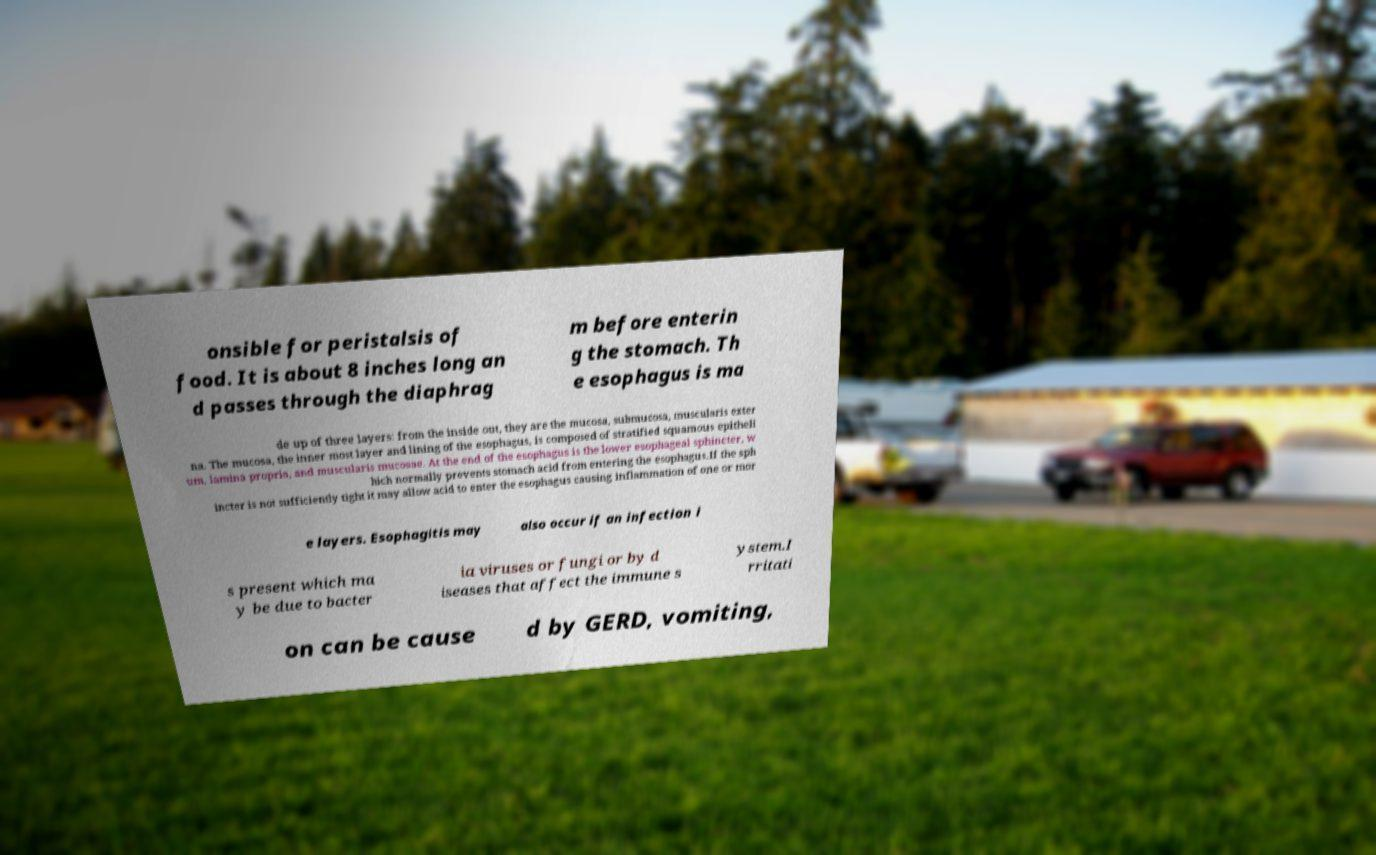Can you accurately transcribe the text from the provided image for me? onsible for peristalsis of food. It is about 8 inches long an d passes through the diaphrag m before enterin g the stomach. Th e esophagus is ma de up of three layers: from the inside out, they are the mucosa, submucosa, muscularis exter na. The mucosa, the inner most layer and lining of the esophagus, is composed of stratified squamous epitheli um, lamina propria, and muscularis mucosae. At the end of the esophagus is the lower esophageal sphincter, w hich normally prevents stomach acid from entering the esophagus.If the sph incter is not sufficiently tight it may allow acid to enter the esophagus causing inflammation of one or mor e layers. Esophagitis may also occur if an infection i s present which ma y be due to bacter ia viruses or fungi or by d iseases that affect the immune s ystem.I rritati on can be cause d by GERD, vomiting, 